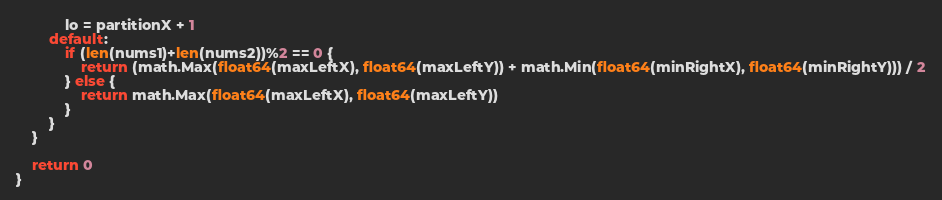<code> <loc_0><loc_0><loc_500><loc_500><_Go_>			lo = partitionX + 1
		default:
			if (len(nums1)+len(nums2))%2 == 0 {
				return (math.Max(float64(maxLeftX), float64(maxLeftY)) + math.Min(float64(minRightX), float64(minRightY))) / 2
			} else {
				return math.Max(float64(maxLeftX), float64(maxLeftY))
			}
		}
	}

	return 0
}
</code> 